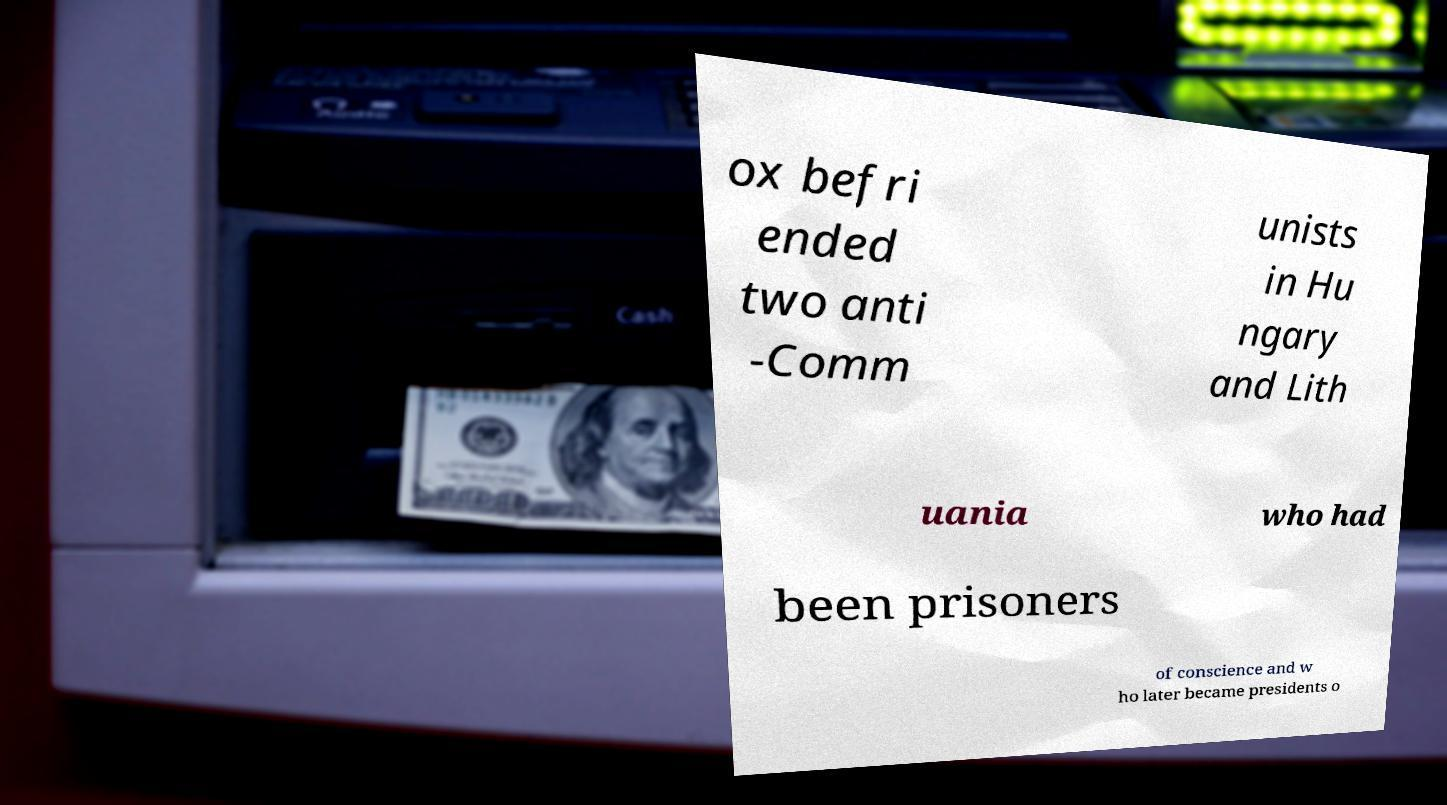There's text embedded in this image that I need extracted. Can you transcribe it verbatim? ox befri ended two anti -Comm unists in Hu ngary and Lith uania who had been prisoners of conscience and w ho later became presidents o 